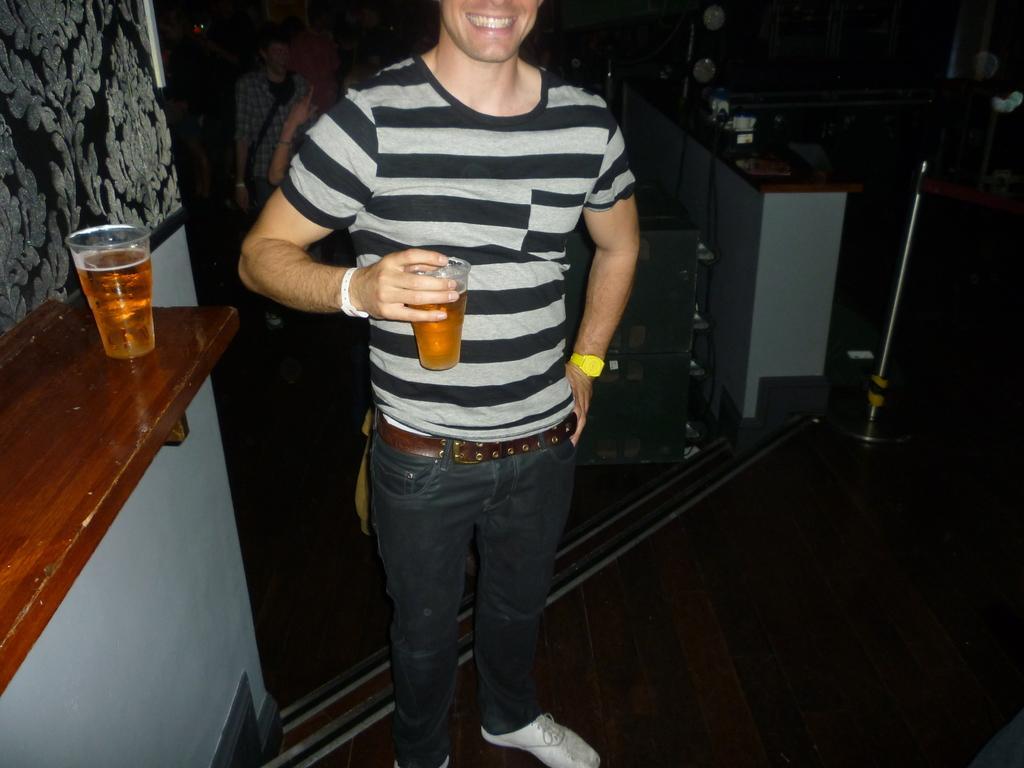How would you summarize this image in a sentence or two? In this image there is a man who is standing and posing for a picture by holding the glass in his hand. Beside him there is a table on which there is another glass. In the background there are few people who are walking. To the right side there is a pole and a table on which it has paste,clock,file on it. 